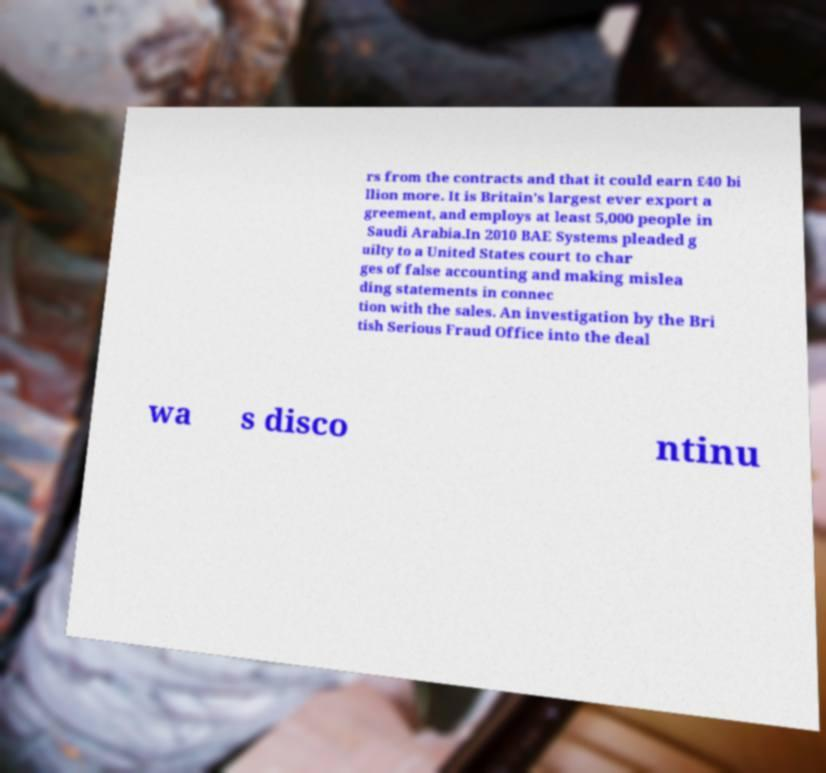Could you extract and type out the text from this image? rs from the contracts and that it could earn £40 bi llion more. It is Britain's largest ever export a greement, and employs at least 5,000 people in Saudi Arabia.In 2010 BAE Systems pleaded g uilty to a United States court to char ges of false accounting and making mislea ding statements in connec tion with the sales. An investigation by the Bri tish Serious Fraud Office into the deal wa s disco ntinu 